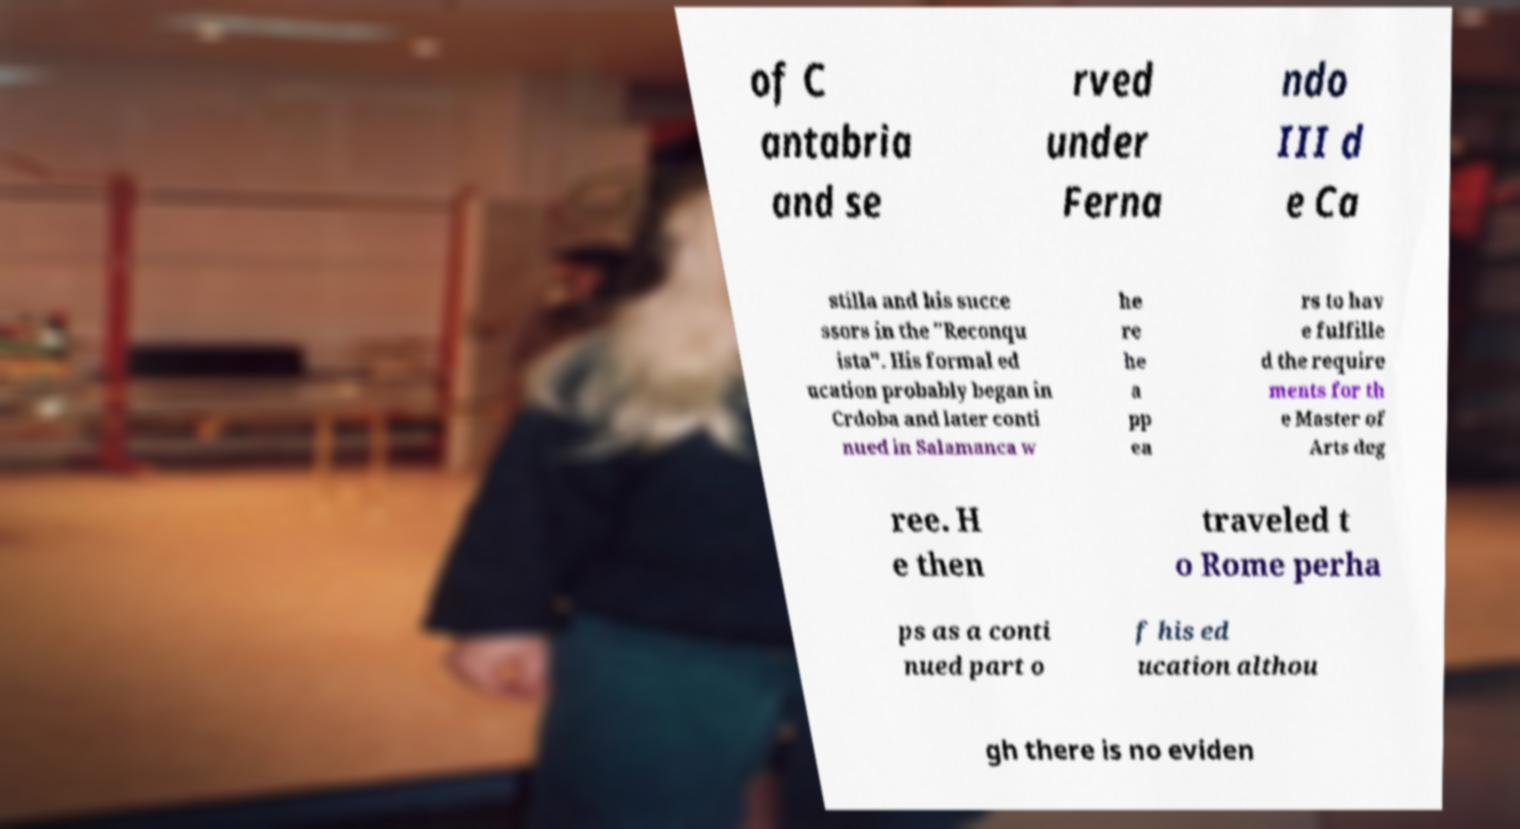Can you accurately transcribe the text from the provided image for me? of C antabria and se rved under Ferna ndo III d e Ca stilla and his succe ssors in the "Reconqu ista". His formal ed ucation probably began in Crdoba and later conti nued in Salamanca w he re he a pp ea rs to hav e fulfille d the require ments for th e Master of Arts deg ree. H e then traveled t o Rome perha ps as a conti nued part o f his ed ucation althou gh there is no eviden 